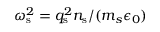<formula> <loc_0><loc_0><loc_500><loc_500>\omega _ { s } ^ { 2 } = q _ { s } ^ { 2 } n _ { s } / ( m _ { s } \epsilon _ { 0 } )</formula> 